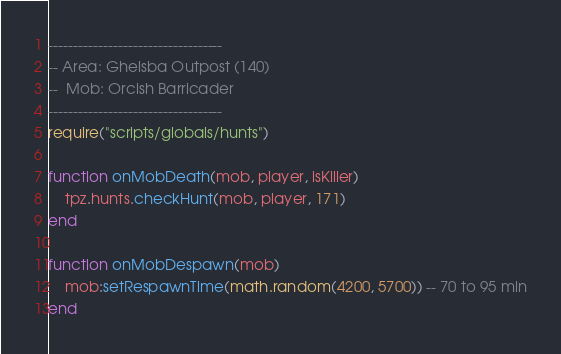<code> <loc_0><loc_0><loc_500><loc_500><_Lua_>-----------------------------------
-- Area: Ghelsba Outpost (140)
--  Mob: Orcish Barricader
-----------------------------------
require("scripts/globals/hunts")

function onMobDeath(mob, player, isKiller)
    tpz.hunts.checkHunt(mob, player, 171)
end

function onMobDespawn(mob)
    mob:setRespawnTime(math.random(4200, 5700)) -- 70 to 95 min
end
</code> 